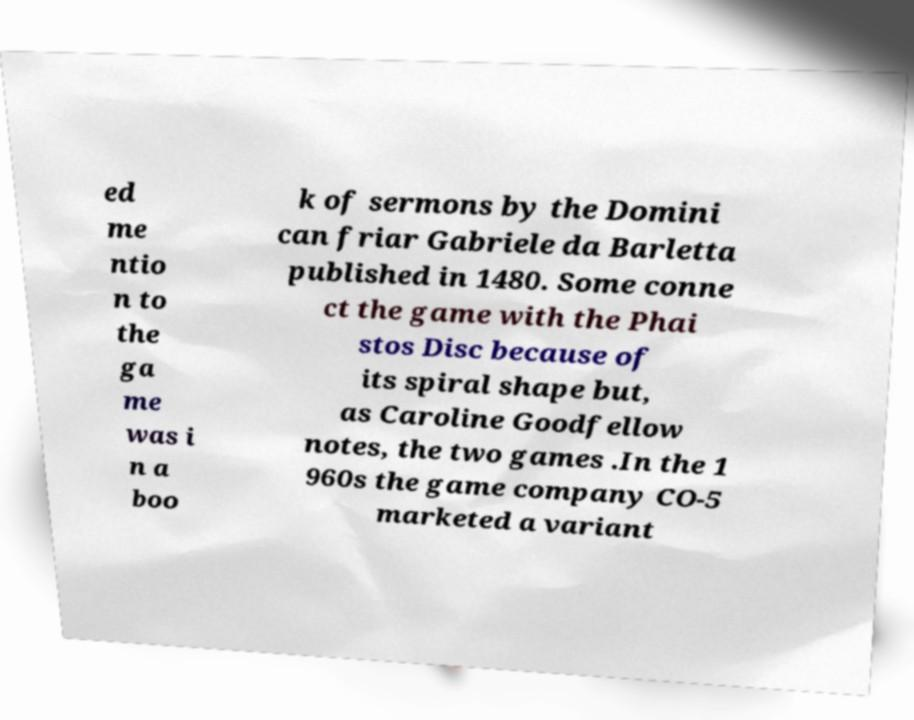Can you accurately transcribe the text from the provided image for me? ed me ntio n to the ga me was i n a boo k of sermons by the Domini can friar Gabriele da Barletta published in 1480. Some conne ct the game with the Phai stos Disc because of its spiral shape but, as Caroline Goodfellow notes, the two games .In the 1 960s the game company CO-5 marketed a variant 